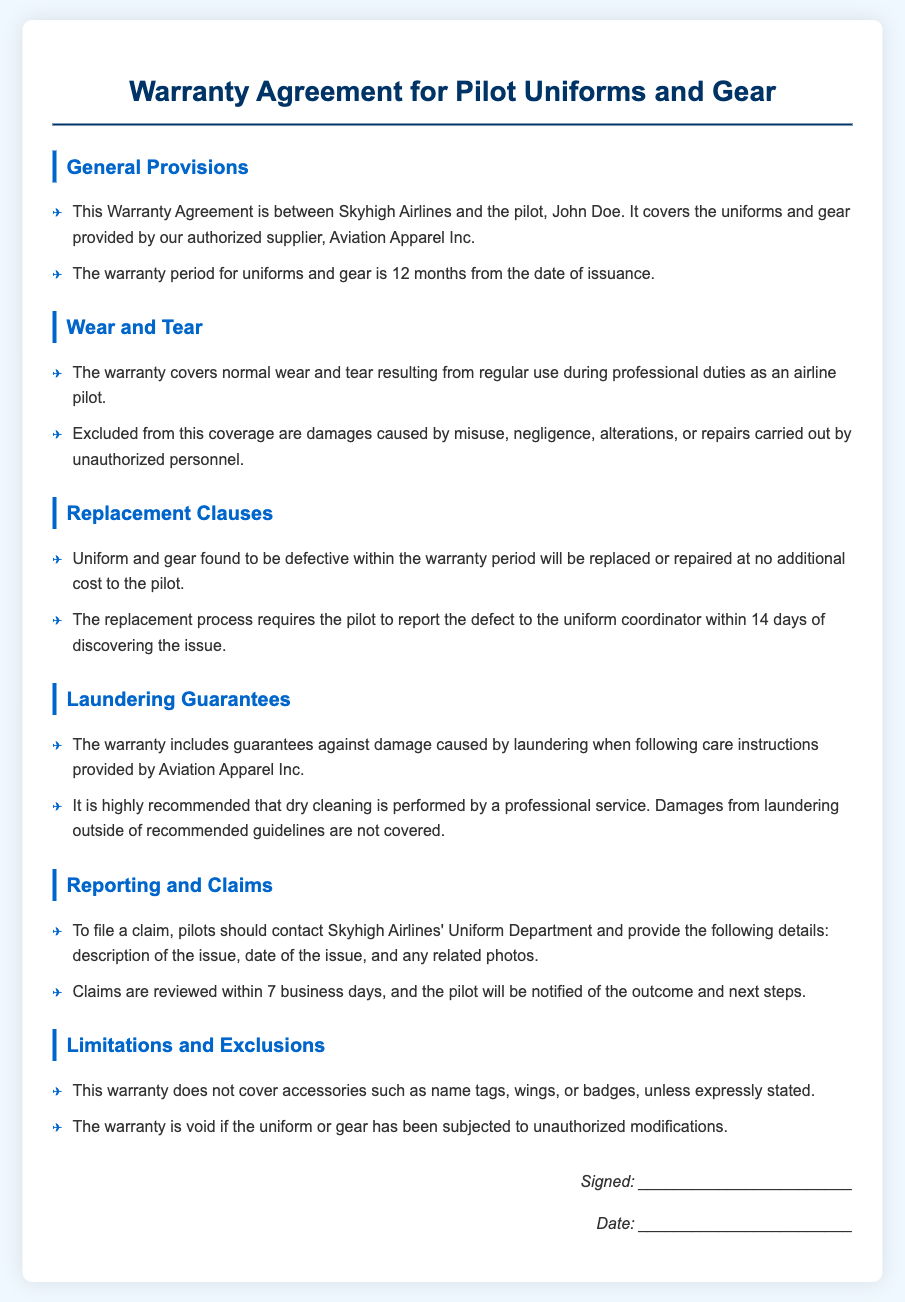What is the warranty period for the uniforms and gear? The warranty period is specified in the document as lasting for 12 months from the date of issuance.
Answer: 12 months What should a pilot do if they find a defect? The document states that the pilot must report the defect to the uniform coordinator within a certain timeframe.
Answer: Report within 14 days What does the warranty cover regarding wear and tear? The document outlines that normal wear and tear resulting from regular use is covered under the warranty.
Answer: Normal wear and tear What type of damages are excluded from wear and tear coverage? The document lists specific circumstances under which coverage is not provided, including damages caused by neglect or unauthorized alterations.
Answer: Misuse, negligence, alterations What is required to file a warranty claim? The document indicates that pilots need to provide certain details when filing a claim with the Uniform Department.
Answer: Description of the issue, date of the issue, photos What does the warranty guarantee regarding laundering? The document confirms that the warranty includes guarantees against damage when proper care instructions are followed.
Answer: Damage during proper laundering What happens if the uniforms have unauthorized modifications? The document specifies that the warranty becomes void if the uniform has unauthorized modifications.
Answer: Warranty is void What items are not covered by this warranty? The document explicitly states that certain accessories are excluded from the warranty coverage.
Answer: Name tags, wings, badges 